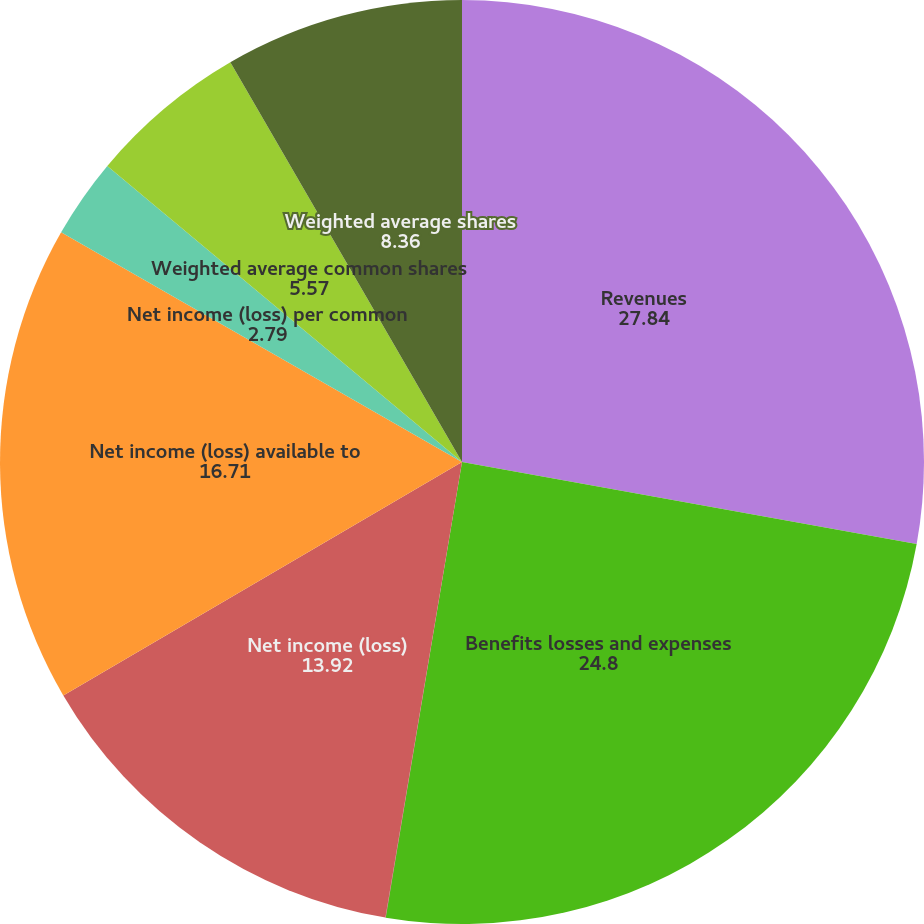<chart> <loc_0><loc_0><loc_500><loc_500><pie_chart><fcel>Revenues<fcel>Benefits losses and expenses<fcel>Income (loss) from continuing<fcel>Net income (loss)<fcel>Net income (loss) available to<fcel>Net income (loss) per common<fcel>Weighted average common shares<fcel>Weighted average shares<nl><fcel>27.84%<fcel>24.8%<fcel>0.01%<fcel>13.92%<fcel>16.71%<fcel>2.79%<fcel>5.57%<fcel>8.36%<nl></chart> 